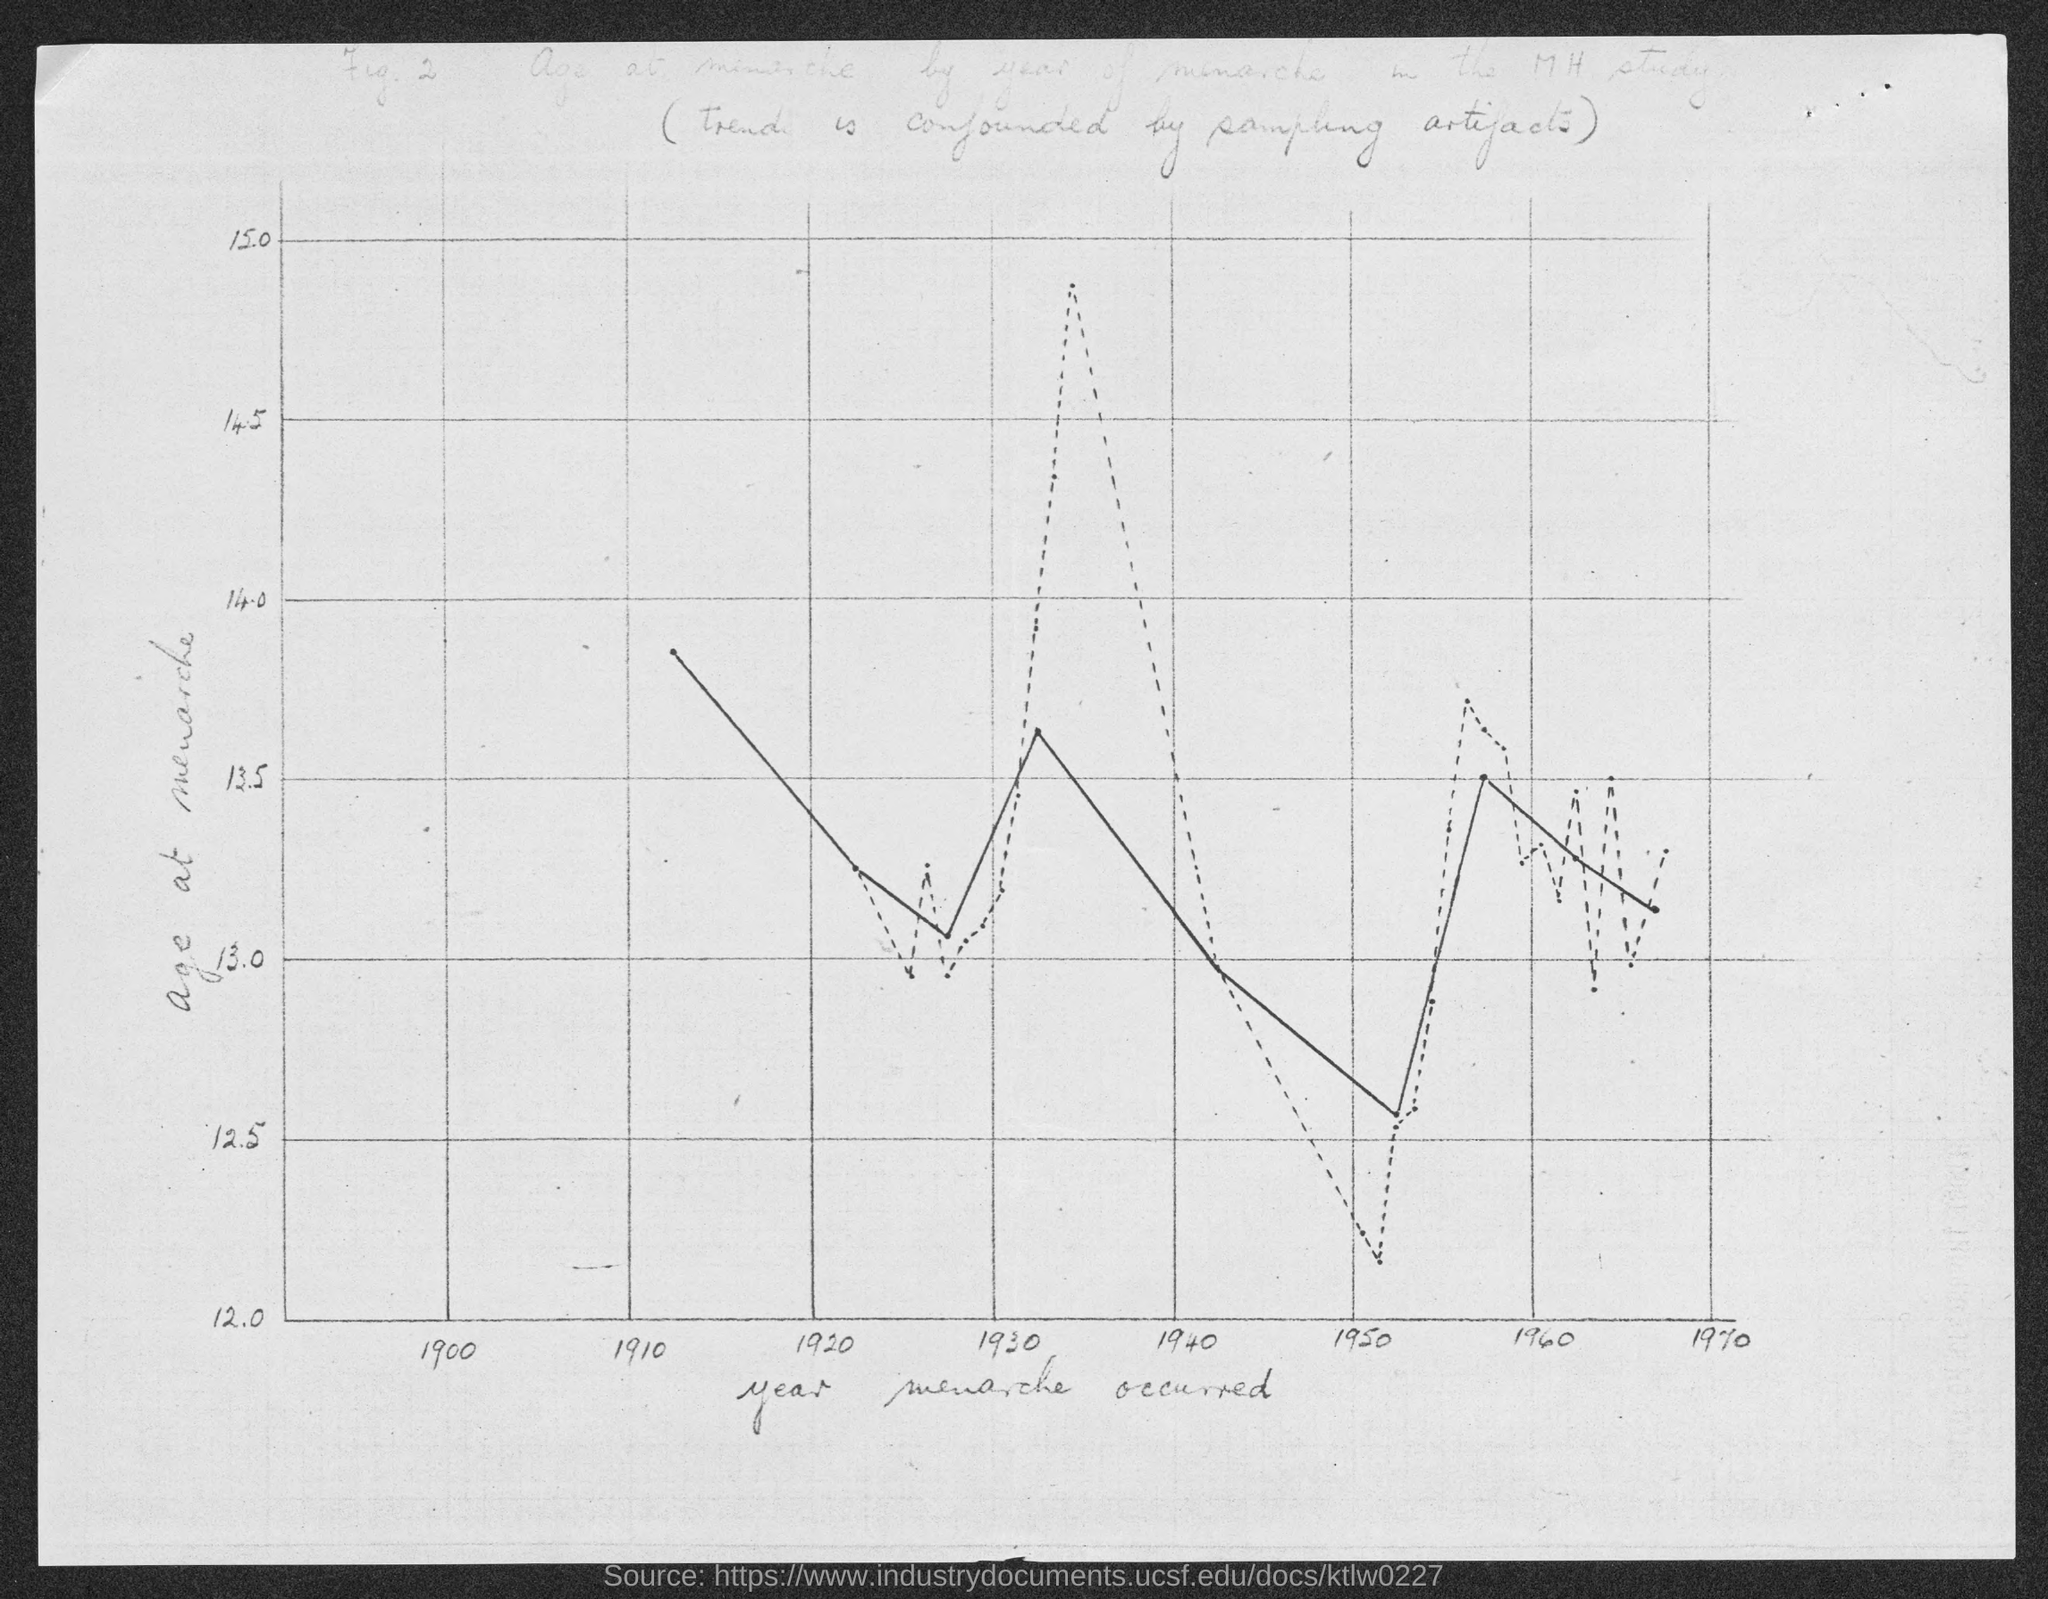Mention a couple of crucial points in this snapshot. The year mentioned first on the x-axis is 1900. 